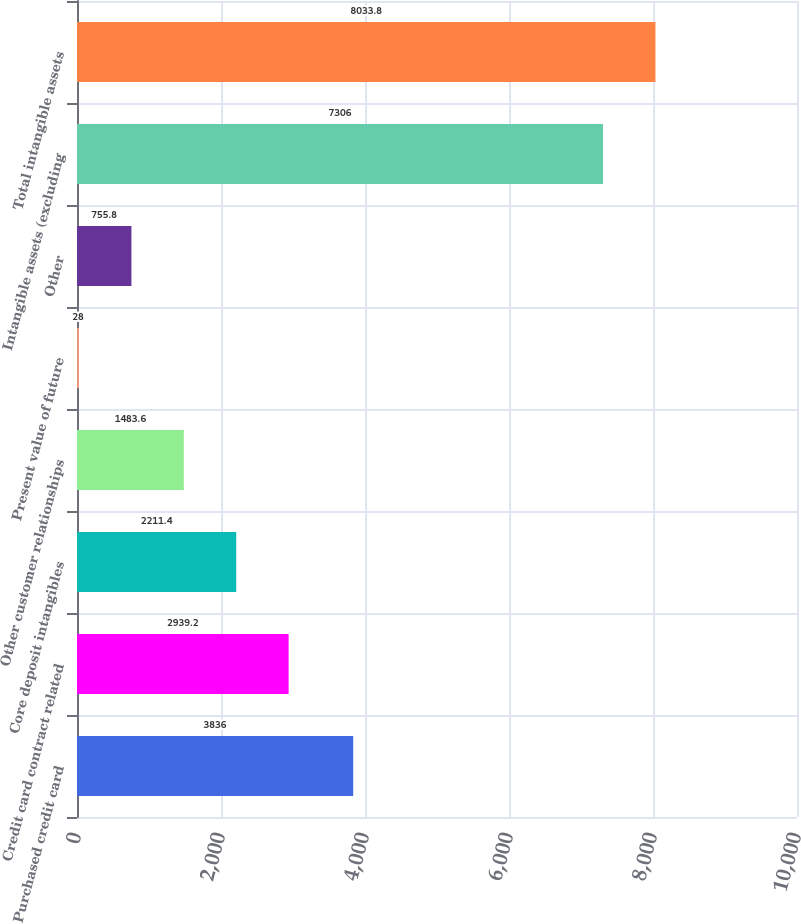Convert chart. <chart><loc_0><loc_0><loc_500><loc_500><bar_chart><fcel>Purchased credit card<fcel>Credit card contract related<fcel>Core deposit intangibles<fcel>Other customer relationships<fcel>Present value of future<fcel>Other<fcel>Intangible assets (excluding<fcel>Total intangible assets<nl><fcel>3836<fcel>2939.2<fcel>2211.4<fcel>1483.6<fcel>28<fcel>755.8<fcel>7306<fcel>8033.8<nl></chart> 